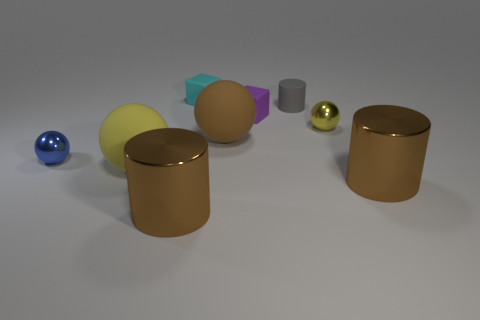How many objects are either purple objects or big objects on the left side of the tiny purple rubber cube?
Ensure brevity in your answer.  4. Is there a purple block that has the same material as the brown sphere?
Offer a terse response. Yes. How many objects are behind the purple matte cube and right of the tiny gray cylinder?
Offer a very short reply. 0. There is a cube that is behind the gray matte object; what material is it?
Keep it short and to the point. Rubber. The yellow thing that is made of the same material as the small blue object is what size?
Make the answer very short. Small. There is a small purple matte block; are there any big brown rubber spheres in front of it?
Your answer should be compact. Yes. There is a yellow metal thing that is the same shape as the blue thing; what size is it?
Provide a succinct answer. Small. Does the tiny cylinder have the same color as the tiny metallic sphere to the left of the tiny yellow metallic sphere?
Your response must be concise. No. Is the number of big blue rubber cubes less than the number of tiny cyan cubes?
Give a very brief answer. Yes. What number of other objects are there of the same color as the small rubber cylinder?
Ensure brevity in your answer.  0. 